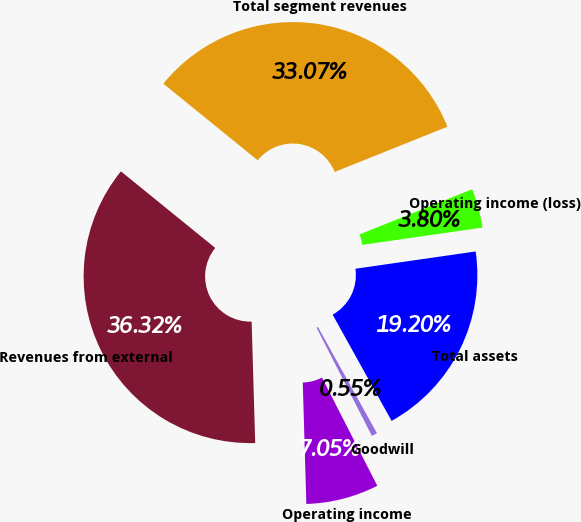Convert chart. <chart><loc_0><loc_0><loc_500><loc_500><pie_chart><fcel>Total segment revenues<fcel>Revenues from external<fcel>Operating income<fcel>Goodwill<fcel>Total assets<fcel>Operating income (loss)<nl><fcel>33.07%<fcel>36.32%<fcel>7.05%<fcel>0.55%<fcel>19.2%<fcel>3.8%<nl></chart> 